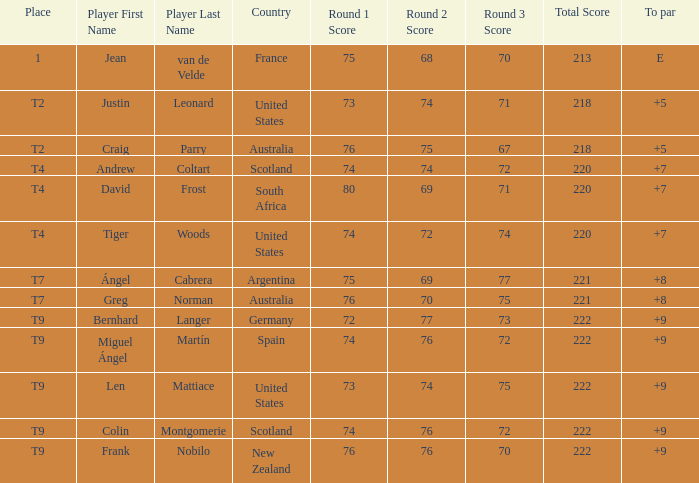Which player from Scotland has a To Par score of +7? Andrew Coltart. I'm looking to parse the entire table for insights. Could you assist me with that? {'header': ['Place', 'Player First Name', 'Player Last Name', 'Country', 'Round 1 Score', 'Round 2 Score', 'Round 3 Score', 'Total Score', 'To par'], 'rows': [['1', 'Jean', 'van de Velde', 'France', '75', '68', '70', '213', 'E'], ['T2', 'Justin', 'Leonard', 'United States', '73', '74', '71', '218', '+5'], ['T2', 'Craig', 'Parry', 'Australia', '76', '75', '67', '218', '+5'], ['T4', 'Andrew', 'Coltart', 'Scotland', '74', '74', '72', '220', '+7'], ['T4', 'David', 'Frost', 'South Africa', '80', '69', '71', '220', '+7'], ['T4', 'Tiger', 'Woods', 'United States', '74', '72', '74', '220', '+7'], ['T7', 'Ángel', 'Cabrera', 'Argentina', '75', '69', '77', '221', '+8'], ['T7', 'Greg', 'Norman', 'Australia', '76', '70', '75', '221', '+8'], ['T9', 'Bernhard', 'Langer', 'Germany', '72', '77', '73', '222', '+9'], ['T9', 'Miguel Ángel', 'Martín', 'Spain', '74', '76', '72', '222', '+9'], ['T9', 'Len', 'Mattiace', 'United States', '73', '74', '75', '222', '+9'], ['T9', 'Colin', 'Montgomerie', 'Scotland', '74', '76', '72', '222', '+9'], ['T9', 'Frank', 'Nobilo', 'New Zealand', '76', '76', '70', '222', '+9']]} 